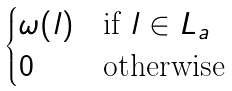Convert formula to latex. <formula><loc_0><loc_0><loc_500><loc_500>\begin{cases} \omega ( l ) & \text {if } l \in L _ { a } \\ 0 & \text {otherwise} \end{cases}</formula> 